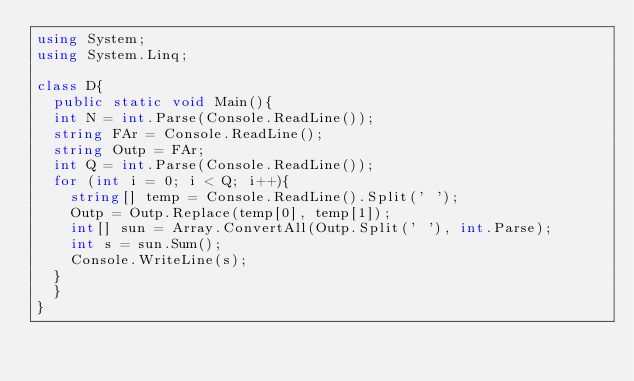Convert code to text. <code><loc_0><loc_0><loc_500><loc_500><_C#_>using System;
using System.Linq;

class D{
  public static void Main(){
  int N = int.Parse(Console.ReadLine());
  string FAr = Console.ReadLine();
  string Outp = FAr;
  int Q = int.Parse(Console.ReadLine());
  for (int i = 0; i < Q; i++){
    string[] temp = Console.ReadLine().Split(' ');
    Outp = Outp.Replace(temp[0], temp[1]);
    int[] sun = Array.ConvertAll(Outp.Split(' '), int.Parse);
    int s = sun.Sum();
    Console.WriteLine(s);
  }
  }
}</code> 